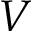<formula> <loc_0><loc_0><loc_500><loc_500>V</formula> 